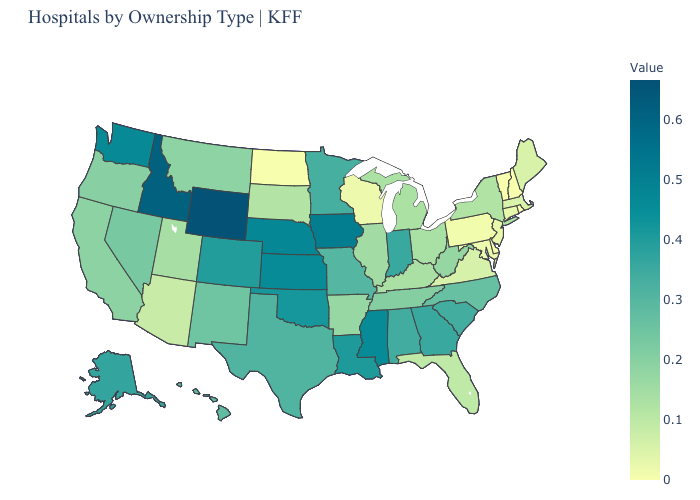Among the states that border Ohio , which have the lowest value?
Quick response, please. Pennsylvania. Which states hav the highest value in the MidWest?
Give a very brief answer. Iowa. Does Wyoming have the highest value in the USA?
Short answer required. Yes. Among the states that border Connecticut , does Rhode Island have the highest value?
Quick response, please. No. Among the states that border Kansas , does Nebraska have the highest value?
Concise answer only. Yes. Does the map have missing data?
Be succinct. No. Which states have the lowest value in the West?
Be succinct. Arizona. Among the states that border Nebraska , which have the highest value?
Answer briefly. Wyoming. Does Wyoming have the highest value in the West?
Concise answer only. Yes. 